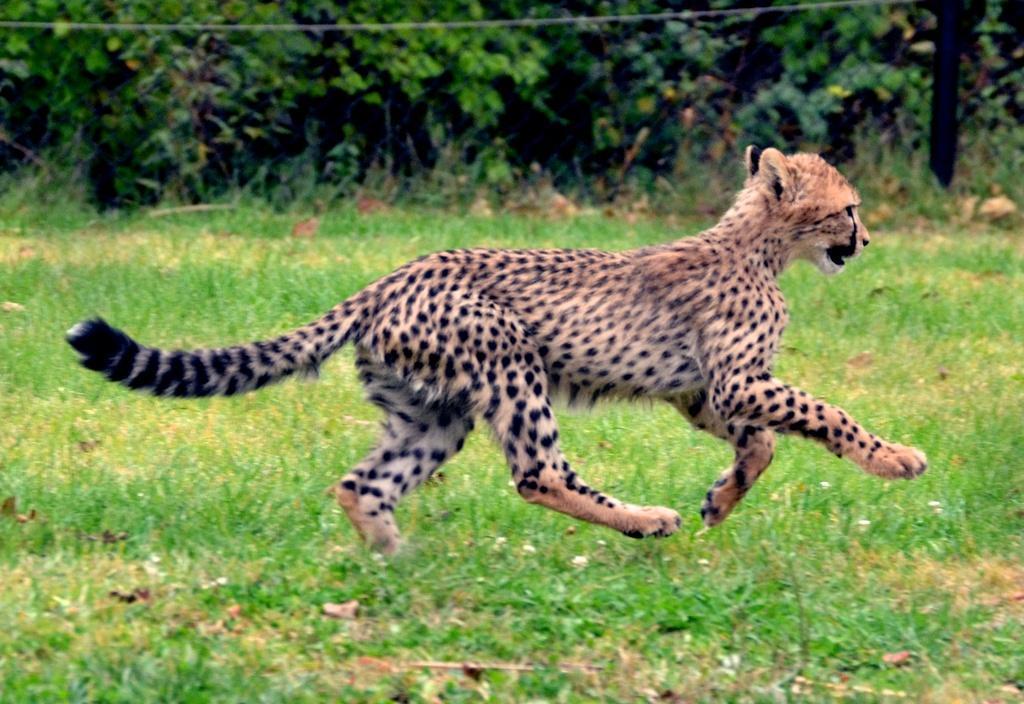How would you summarize this image in a sentence or two? There is a cheetah running on the grass. In the background there are trees. 